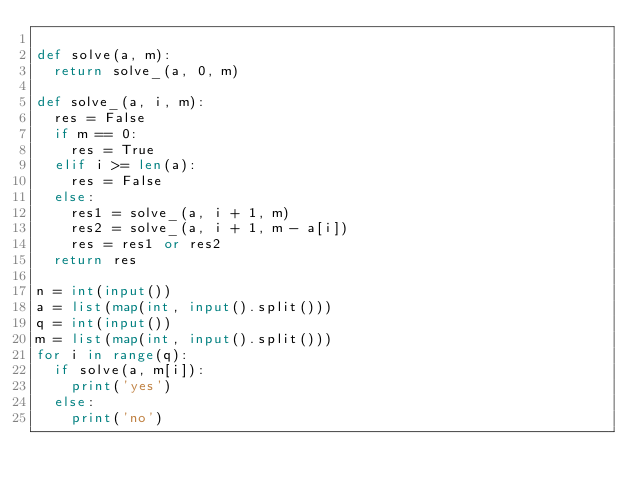<code> <loc_0><loc_0><loc_500><loc_500><_Python_>
def solve(a, m):
	return solve_(a, 0, m)

def solve_(a, i, m):
	res = False
	if m == 0:
		res = True
	elif i >= len(a):
		res = False
	else:
		res1 = solve_(a, i + 1, m)
		res2 = solve_(a, i + 1, m - a[i])
		res = res1 or res2
	return res

n = int(input())
a = list(map(int, input().split()))
q = int(input())
m = list(map(int, input().split()))
for i in range(q):
	if solve(a, m[i]):
		print('yes')
	else:
		print('no')

</code> 